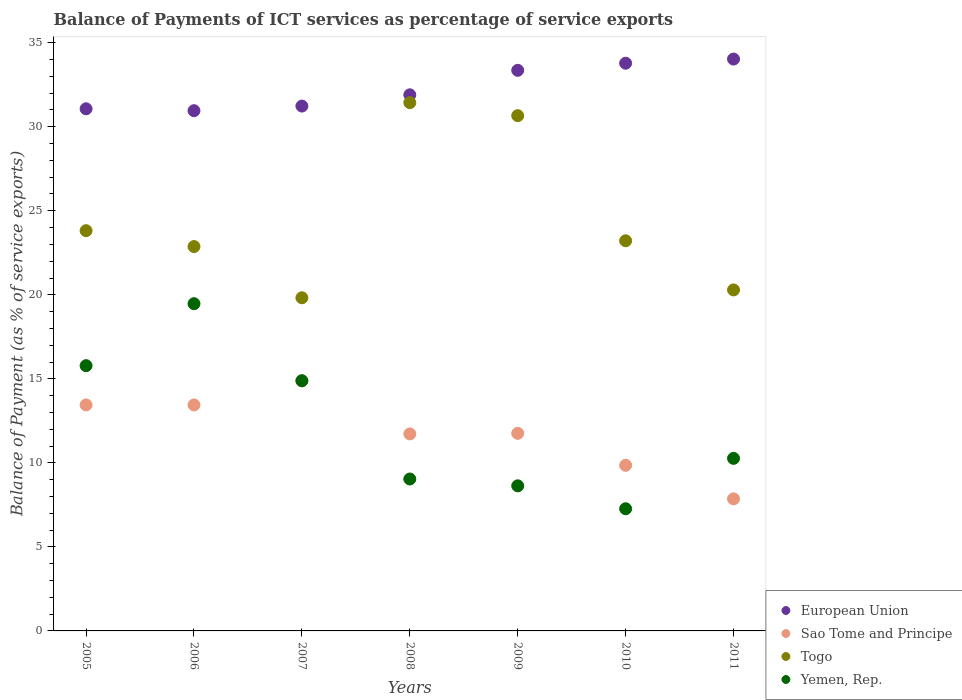How many different coloured dotlines are there?
Ensure brevity in your answer.  4. What is the balance of payments of ICT services in Togo in 2005?
Provide a succinct answer. 23.82. Across all years, what is the maximum balance of payments of ICT services in European Union?
Your answer should be compact. 34.03. Across all years, what is the minimum balance of payments of ICT services in Togo?
Your answer should be compact. 19.82. What is the total balance of payments of ICT services in Sao Tome and Principe in the graph?
Ensure brevity in your answer.  82.96. What is the difference between the balance of payments of ICT services in Togo in 2008 and that in 2010?
Make the answer very short. 8.22. What is the difference between the balance of payments of ICT services in Yemen, Rep. in 2006 and the balance of payments of ICT services in European Union in 2011?
Keep it short and to the point. -14.56. What is the average balance of payments of ICT services in Togo per year?
Make the answer very short. 24.59. In the year 2005, what is the difference between the balance of payments of ICT services in Togo and balance of payments of ICT services in Yemen, Rep.?
Provide a succinct answer. 8.03. What is the ratio of the balance of payments of ICT services in Yemen, Rep. in 2006 to that in 2009?
Your response must be concise. 2.26. Is the balance of payments of ICT services in European Union in 2008 less than that in 2010?
Offer a terse response. Yes. What is the difference between the highest and the second highest balance of payments of ICT services in Yemen, Rep.?
Offer a terse response. 3.69. What is the difference between the highest and the lowest balance of payments of ICT services in Yemen, Rep.?
Provide a short and direct response. 12.2. Is the sum of the balance of payments of ICT services in Yemen, Rep. in 2005 and 2006 greater than the maximum balance of payments of ICT services in Togo across all years?
Offer a terse response. Yes. Is it the case that in every year, the sum of the balance of payments of ICT services in Togo and balance of payments of ICT services in Sao Tome and Principe  is greater than the sum of balance of payments of ICT services in Yemen, Rep. and balance of payments of ICT services in European Union?
Your response must be concise. No. Is the balance of payments of ICT services in European Union strictly greater than the balance of payments of ICT services in Togo over the years?
Provide a succinct answer. Yes. Is the balance of payments of ICT services in European Union strictly less than the balance of payments of ICT services in Sao Tome and Principe over the years?
Offer a very short reply. No. How many dotlines are there?
Keep it short and to the point. 4. Does the graph contain any zero values?
Give a very brief answer. No. Does the graph contain grids?
Your response must be concise. No. Where does the legend appear in the graph?
Offer a terse response. Bottom right. How many legend labels are there?
Give a very brief answer. 4. How are the legend labels stacked?
Give a very brief answer. Vertical. What is the title of the graph?
Provide a succinct answer. Balance of Payments of ICT services as percentage of service exports. Does "Japan" appear as one of the legend labels in the graph?
Ensure brevity in your answer.  No. What is the label or title of the Y-axis?
Your answer should be compact. Balance of Payment (as % of service exports). What is the Balance of Payment (as % of service exports) in European Union in 2005?
Ensure brevity in your answer.  31.07. What is the Balance of Payment (as % of service exports) in Sao Tome and Principe in 2005?
Your response must be concise. 13.45. What is the Balance of Payment (as % of service exports) in Togo in 2005?
Provide a short and direct response. 23.82. What is the Balance of Payment (as % of service exports) in Yemen, Rep. in 2005?
Provide a short and direct response. 15.78. What is the Balance of Payment (as % of service exports) of European Union in 2006?
Keep it short and to the point. 30.96. What is the Balance of Payment (as % of service exports) of Sao Tome and Principe in 2006?
Offer a terse response. 13.45. What is the Balance of Payment (as % of service exports) of Togo in 2006?
Provide a short and direct response. 22.87. What is the Balance of Payment (as % of service exports) in Yemen, Rep. in 2006?
Keep it short and to the point. 19.47. What is the Balance of Payment (as % of service exports) in European Union in 2007?
Your answer should be compact. 31.23. What is the Balance of Payment (as % of service exports) in Sao Tome and Principe in 2007?
Offer a very short reply. 14.87. What is the Balance of Payment (as % of service exports) in Togo in 2007?
Provide a short and direct response. 19.82. What is the Balance of Payment (as % of service exports) in Yemen, Rep. in 2007?
Give a very brief answer. 14.89. What is the Balance of Payment (as % of service exports) in European Union in 2008?
Keep it short and to the point. 31.9. What is the Balance of Payment (as % of service exports) of Sao Tome and Principe in 2008?
Your answer should be compact. 11.72. What is the Balance of Payment (as % of service exports) in Togo in 2008?
Your answer should be compact. 31.43. What is the Balance of Payment (as % of service exports) in Yemen, Rep. in 2008?
Make the answer very short. 9.04. What is the Balance of Payment (as % of service exports) in European Union in 2009?
Give a very brief answer. 33.36. What is the Balance of Payment (as % of service exports) in Sao Tome and Principe in 2009?
Ensure brevity in your answer.  11.76. What is the Balance of Payment (as % of service exports) of Togo in 2009?
Make the answer very short. 30.66. What is the Balance of Payment (as % of service exports) in Yemen, Rep. in 2009?
Keep it short and to the point. 8.63. What is the Balance of Payment (as % of service exports) in European Union in 2010?
Your answer should be compact. 33.78. What is the Balance of Payment (as % of service exports) in Sao Tome and Principe in 2010?
Provide a succinct answer. 9.85. What is the Balance of Payment (as % of service exports) in Togo in 2010?
Offer a terse response. 23.22. What is the Balance of Payment (as % of service exports) of Yemen, Rep. in 2010?
Your response must be concise. 7.27. What is the Balance of Payment (as % of service exports) of European Union in 2011?
Offer a very short reply. 34.03. What is the Balance of Payment (as % of service exports) in Sao Tome and Principe in 2011?
Your answer should be compact. 7.86. What is the Balance of Payment (as % of service exports) of Togo in 2011?
Your answer should be very brief. 20.29. What is the Balance of Payment (as % of service exports) of Yemen, Rep. in 2011?
Your response must be concise. 10.27. Across all years, what is the maximum Balance of Payment (as % of service exports) of European Union?
Your answer should be very brief. 34.03. Across all years, what is the maximum Balance of Payment (as % of service exports) in Sao Tome and Principe?
Your response must be concise. 14.87. Across all years, what is the maximum Balance of Payment (as % of service exports) of Togo?
Your answer should be very brief. 31.43. Across all years, what is the maximum Balance of Payment (as % of service exports) of Yemen, Rep.?
Ensure brevity in your answer.  19.47. Across all years, what is the minimum Balance of Payment (as % of service exports) in European Union?
Your response must be concise. 30.96. Across all years, what is the minimum Balance of Payment (as % of service exports) of Sao Tome and Principe?
Provide a succinct answer. 7.86. Across all years, what is the minimum Balance of Payment (as % of service exports) in Togo?
Offer a very short reply. 19.82. Across all years, what is the minimum Balance of Payment (as % of service exports) in Yemen, Rep.?
Provide a succinct answer. 7.27. What is the total Balance of Payment (as % of service exports) of European Union in the graph?
Offer a terse response. 226.33. What is the total Balance of Payment (as % of service exports) in Sao Tome and Principe in the graph?
Offer a very short reply. 82.96. What is the total Balance of Payment (as % of service exports) of Togo in the graph?
Provide a succinct answer. 172.11. What is the total Balance of Payment (as % of service exports) of Yemen, Rep. in the graph?
Keep it short and to the point. 85.36. What is the difference between the Balance of Payment (as % of service exports) of European Union in 2005 and that in 2006?
Give a very brief answer. 0.11. What is the difference between the Balance of Payment (as % of service exports) of Togo in 2005 and that in 2006?
Your answer should be compact. 0.94. What is the difference between the Balance of Payment (as % of service exports) in Yemen, Rep. in 2005 and that in 2006?
Offer a very short reply. -3.69. What is the difference between the Balance of Payment (as % of service exports) in European Union in 2005 and that in 2007?
Ensure brevity in your answer.  -0.16. What is the difference between the Balance of Payment (as % of service exports) in Sao Tome and Principe in 2005 and that in 2007?
Your response must be concise. -1.43. What is the difference between the Balance of Payment (as % of service exports) of Togo in 2005 and that in 2007?
Provide a short and direct response. 3.99. What is the difference between the Balance of Payment (as % of service exports) in Yemen, Rep. in 2005 and that in 2007?
Your answer should be compact. 0.89. What is the difference between the Balance of Payment (as % of service exports) of European Union in 2005 and that in 2008?
Give a very brief answer. -0.83. What is the difference between the Balance of Payment (as % of service exports) of Sao Tome and Principe in 2005 and that in 2008?
Make the answer very short. 1.72. What is the difference between the Balance of Payment (as % of service exports) of Togo in 2005 and that in 2008?
Ensure brevity in your answer.  -7.62. What is the difference between the Balance of Payment (as % of service exports) in Yemen, Rep. in 2005 and that in 2008?
Make the answer very short. 6.74. What is the difference between the Balance of Payment (as % of service exports) of European Union in 2005 and that in 2009?
Offer a very short reply. -2.29. What is the difference between the Balance of Payment (as % of service exports) of Sao Tome and Principe in 2005 and that in 2009?
Your answer should be compact. 1.69. What is the difference between the Balance of Payment (as % of service exports) in Togo in 2005 and that in 2009?
Offer a terse response. -6.84. What is the difference between the Balance of Payment (as % of service exports) in Yemen, Rep. in 2005 and that in 2009?
Offer a very short reply. 7.15. What is the difference between the Balance of Payment (as % of service exports) in European Union in 2005 and that in 2010?
Offer a terse response. -2.71. What is the difference between the Balance of Payment (as % of service exports) of Sao Tome and Principe in 2005 and that in 2010?
Provide a short and direct response. 3.59. What is the difference between the Balance of Payment (as % of service exports) of Togo in 2005 and that in 2010?
Keep it short and to the point. 0.6. What is the difference between the Balance of Payment (as % of service exports) of Yemen, Rep. in 2005 and that in 2010?
Ensure brevity in your answer.  8.51. What is the difference between the Balance of Payment (as % of service exports) in European Union in 2005 and that in 2011?
Offer a terse response. -2.96. What is the difference between the Balance of Payment (as % of service exports) of Sao Tome and Principe in 2005 and that in 2011?
Offer a very short reply. 5.59. What is the difference between the Balance of Payment (as % of service exports) of Togo in 2005 and that in 2011?
Ensure brevity in your answer.  3.52. What is the difference between the Balance of Payment (as % of service exports) of Yemen, Rep. in 2005 and that in 2011?
Your answer should be compact. 5.51. What is the difference between the Balance of Payment (as % of service exports) in European Union in 2006 and that in 2007?
Your response must be concise. -0.27. What is the difference between the Balance of Payment (as % of service exports) in Sao Tome and Principe in 2006 and that in 2007?
Your response must be concise. -1.43. What is the difference between the Balance of Payment (as % of service exports) of Togo in 2006 and that in 2007?
Give a very brief answer. 3.05. What is the difference between the Balance of Payment (as % of service exports) in Yemen, Rep. in 2006 and that in 2007?
Offer a very short reply. 4.58. What is the difference between the Balance of Payment (as % of service exports) of European Union in 2006 and that in 2008?
Ensure brevity in your answer.  -0.94. What is the difference between the Balance of Payment (as % of service exports) in Sao Tome and Principe in 2006 and that in 2008?
Make the answer very short. 1.72. What is the difference between the Balance of Payment (as % of service exports) in Togo in 2006 and that in 2008?
Make the answer very short. -8.56. What is the difference between the Balance of Payment (as % of service exports) in Yemen, Rep. in 2006 and that in 2008?
Your answer should be very brief. 10.43. What is the difference between the Balance of Payment (as % of service exports) in European Union in 2006 and that in 2009?
Give a very brief answer. -2.4. What is the difference between the Balance of Payment (as % of service exports) of Sao Tome and Principe in 2006 and that in 2009?
Give a very brief answer. 1.69. What is the difference between the Balance of Payment (as % of service exports) of Togo in 2006 and that in 2009?
Offer a very short reply. -7.79. What is the difference between the Balance of Payment (as % of service exports) of Yemen, Rep. in 2006 and that in 2009?
Ensure brevity in your answer.  10.84. What is the difference between the Balance of Payment (as % of service exports) of European Union in 2006 and that in 2010?
Keep it short and to the point. -2.83. What is the difference between the Balance of Payment (as % of service exports) in Sao Tome and Principe in 2006 and that in 2010?
Your answer should be compact. 3.59. What is the difference between the Balance of Payment (as % of service exports) of Togo in 2006 and that in 2010?
Your answer should be compact. -0.34. What is the difference between the Balance of Payment (as % of service exports) in Yemen, Rep. in 2006 and that in 2010?
Give a very brief answer. 12.2. What is the difference between the Balance of Payment (as % of service exports) in European Union in 2006 and that in 2011?
Your answer should be very brief. -3.07. What is the difference between the Balance of Payment (as % of service exports) in Sao Tome and Principe in 2006 and that in 2011?
Your response must be concise. 5.59. What is the difference between the Balance of Payment (as % of service exports) of Togo in 2006 and that in 2011?
Give a very brief answer. 2.58. What is the difference between the Balance of Payment (as % of service exports) in Yemen, Rep. in 2006 and that in 2011?
Your answer should be compact. 9.2. What is the difference between the Balance of Payment (as % of service exports) in European Union in 2007 and that in 2008?
Give a very brief answer. -0.67. What is the difference between the Balance of Payment (as % of service exports) in Sao Tome and Principe in 2007 and that in 2008?
Offer a very short reply. 3.15. What is the difference between the Balance of Payment (as % of service exports) in Togo in 2007 and that in 2008?
Provide a short and direct response. -11.61. What is the difference between the Balance of Payment (as % of service exports) in Yemen, Rep. in 2007 and that in 2008?
Your response must be concise. 5.85. What is the difference between the Balance of Payment (as % of service exports) of European Union in 2007 and that in 2009?
Make the answer very short. -2.13. What is the difference between the Balance of Payment (as % of service exports) of Sao Tome and Principe in 2007 and that in 2009?
Give a very brief answer. 3.12. What is the difference between the Balance of Payment (as % of service exports) of Togo in 2007 and that in 2009?
Your answer should be very brief. -10.84. What is the difference between the Balance of Payment (as % of service exports) of Yemen, Rep. in 2007 and that in 2009?
Make the answer very short. 6.26. What is the difference between the Balance of Payment (as % of service exports) in European Union in 2007 and that in 2010?
Offer a very short reply. -2.55. What is the difference between the Balance of Payment (as % of service exports) in Sao Tome and Principe in 2007 and that in 2010?
Provide a succinct answer. 5.02. What is the difference between the Balance of Payment (as % of service exports) of Togo in 2007 and that in 2010?
Your answer should be very brief. -3.39. What is the difference between the Balance of Payment (as % of service exports) of Yemen, Rep. in 2007 and that in 2010?
Offer a terse response. 7.62. What is the difference between the Balance of Payment (as % of service exports) of European Union in 2007 and that in 2011?
Offer a terse response. -2.8. What is the difference between the Balance of Payment (as % of service exports) in Sao Tome and Principe in 2007 and that in 2011?
Offer a very short reply. 7.01. What is the difference between the Balance of Payment (as % of service exports) of Togo in 2007 and that in 2011?
Make the answer very short. -0.47. What is the difference between the Balance of Payment (as % of service exports) of Yemen, Rep. in 2007 and that in 2011?
Provide a succinct answer. 4.62. What is the difference between the Balance of Payment (as % of service exports) in European Union in 2008 and that in 2009?
Provide a short and direct response. -1.46. What is the difference between the Balance of Payment (as % of service exports) in Sao Tome and Principe in 2008 and that in 2009?
Ensure brevity in your answer.  -0.03. What is the difference between the Balance of Payment (as % of service exports) in Togo in 2008 and that in 2009?
Your answer should be very brief. 0.77. What is the difference between the Balance of Payment (as % of service exports) of Yemen, Rep. in 2008 and that in 2009?
Give a very brief answer. 0.41. What is the difference between the Balance of Payment (as % of service exports) in European Union in 2008 and that in 2010?
Your answer should be very brief. -1.88. What is the difference between the Balance of Payment (as % of service exports) in Sao Tome and Principe in 2008 and that in 2010?
Keep it short and to the point. 1.87. What is the difference between the Balance of Payment (as % of service exports) in Togo in 2008 and that in 2010?
Ensure brevity in your answer.  8.22. What is the difference between the Balance of Payment (as % of service exports) in Yemen, Rep. in 2008 and that in 2010?
Your response must be concise. 1.77. What is the difference between the Balance of Payment (as % of service exports) in European Union in 2008 and that in 2011?
Your answer should be compact. -2.13. What is the difference between the Balance of Payment (as % of service exports) in Sao Tome and Principe in 2008 and that in 2011?
Provide a short and direct response. 3.86. What is the difference between the Balance of Payment (as % of service exports) of Togo in 2008 and that in 2011?
Your response must be concise. 11.14. What is the difference between the Balance of Payment (as % of service exports) in Yemen, Rep. in 2008 and that in 2011?
Your answer should be compact. -1.23. What is the difference between the Balance of Payment (as % of service exports) in European Union in 2009 and that in 2010?
Your response must be concise. -0.42. What is the difference between the Balance of Payment (as % of service exports) in Sao Tome and Principe in 2009 and that in 2010?
Keep it short and to the point. 1.9. What is the difference between the Balance of Payment (as % of service exports) of Togo in 2009 and that in 2010?
Your response must be concise. 7.44. What is the difference between the Balance of Payment (as % of service exports) in Yemen, Rep. in 2009 and that in 2010?
Offer a very short reply. 1.36. What is the difference between the Balance of Payment (as % of service exports) of European Union in 2009 and that in 2011?
Give a very brief answer. -0.67. What is the difference between the Balance of Payment (as % of service exports) of Sao Tome and Principe in 2009 and that in 2011?
Offer a terse response. 3.9. What is the difference between the Balance of Payment (as % of service exports) of Togo in 2009 and that in 2011?
Your answer should be compact. 10.37. What is the difference between the Balance of Payment (as % of service exports) of Yemen, Rep. in 2009 and that in 2011?
Make the answer very short. -1.64. What is the difference between the Balance of Payment (as % of service exports) in European Union in 2010 and that in 2011?
Provide a succinct answer. -0.25. What is the difference between the Balance of Payment (as % of service exports) in Sao Tome and Principe in 2010 and that in 2011?
Your answer should be very brief. 1.99. What is the difference between the Balance of Payment (as % of service exports) in Togo in 2010 and that in 2011?
Give a very brief answer. 2.92. What is the difference between the Balance of Payment (as % of service exports) of Yemen, Rep. in 2010 and that in 2011?
Provide a short and direct response. -3. What is the difference between the Balance of Payment (as % of service exports) in European Union in 2005 and the Balance of Payment (as % of service exports) in Sao Tome and Principe in 2006?
Provide a succinct answer. 17.62. What is the difference between the Balance of Payment (as % of service exports) in European Union in 2005 and the Balance of Payment (as % of service exports) in Togo in 2006?
Your response must be concise. 8.2. What is the difference between the Balance of Payment (as % of service exports) in European Union in 2005 and the Balance of Payment (as % of service exports) in Yemen, Rep. in 2006?
Your answer should be very brief. 11.6. What is the difference between the Balance of Payment (as % of service exports) of Sao Tome and Principe in 2005 and the Balance of Payment (as % of service exports) of Togo in 2006?
Make the answer very short. -9.42. What is the difference between the Balance of Payment (as % of service exports) of Sao Tome and Principe in 2005 and the Balance of Payment (as % of service exports) of Yemen, Rep. in 2006?
Give a very brief answer. -6.02. What is the difference between the Balance of Payment (as % of service exports) in Togo in 2005 and the Balance of Payment (as % of service exports) in Yemen, Rep. in 2006?
Give a very brief answer. 4.34. What is the difference between the Balance of Payment (as % of service exports) in European Union in 2005 and the Balance of Payment (as % of service exports) in Sao Tome and Principe in 2007?
Make the answer very short. 16.2. What is the difference between the Balance of Payment (as % of service exports) in European Union in 2005 and the Balance of Payment (as % of service exports) in Togo in 2007?
Provide a succinct answer. 11.25. What is the difference between the Balance of Payment (as % of service exports) in European Union in 2005 and the Balance of Payment (as % of service exports) in Yemen, Rep. in 2007?
Keep it short and to the point. 16.18. What is the difference between the Balance of Payment (as % of service exports) of Sao Tome and Principe in 2005 and the Balance of Payment (as % of service exports) of Togo in 2007?
Provide a succinct answer. -6.38. What is the difference between the Balance of Payment (as % of service exports) of Sao Tome and Principe in 2005 and the Balance of Payment (as % of service exports) of Yemen, Rep. in 2007?
Your response must be concise. -1.44. What is the difference between the Balance of Payment (as % of service exports) in Togo in 2005 and the Balance of Payment (as % of service exports) in Yemen, Rep. in 2007?
Your response must be concise. 8.93. What is the difference between the Balance of Payment (as % of service exports) in European Union in 2005 and the Balance of Payment (as % of service exports) in Sao Tome and Principe in 2008?
Make the answer very short. 19.35. What is the difference between the Balance of Payment (as % of service exports) of European Union in 2005 and the Balance of Payment (as % of service exports) of Togo in 2008?
Provide a short and direct response. -0.36. What is the difference between the Balance of Payment (as % of service exports) in European Union in 2005 and the Balance of Payment (as % of service exports) in Yemen, Rep. in 2008?
Make the answer very short. 22.03. What is the difference between the Balance of Payment (as % of service exports) in Sao Tome and Principe in 2005 and the Balance of Payment (as % of service exports) in Togo in 2008?
Ensure brevity in your answer.  -17.99. What is the difference between the Balance of Payment (as % of service exports) of Sao Tome and Principe in 2005 and the Balance of Payment (as % of service exports) of Yemen, Rep. in 2008?
Ensure brevity in your answer.  4.41. What is the difference between the Balance of Payment (as % of service exports) in Togo in 2005 and the Balance of Payment (as % of service exports) in Yemen, Rep. in 2008?
Your answer should be compact. 14.78. What is the difference between the Balance of Payment (as % of service exports) of European Union in 2005 and the Balance of Payment (as % of service exports) of Sao Tome and Principe in 2009?
Provide a succinct answer. 19.31. What is the difference between the Balance of Payment (as % of service exports) of European Union in 2005 and the Balance of Payment (as % of service exports) of Togo in 2009?
Make the answer very short. 0.41. What is the difference between the Balance of Payment (as % of service exports) in European Union in 2005 and the Balance of Payment (as % of service exports) in Yemen, Rep. in 2009?
Your answer should be compact. 22.44. What is the difference between the Balance of Payment (as % of service exports) of Sao Tome and Principe in 2005 and the Balance of Payment (as % of service exports) of Togo in 2009?
Your answer should be very brief. -17.21. What is the difference between the Balance of Payment (as % of service exports) in Sao Tome and Principe in 2005 and the Balance of Payment (as % of service exports) in Yemen, Rep. in 2009?
Provide a succinct answer. 4.81. What is the difference between the Balance of Payment (as % of service exports) in Togo in 2005 and the Balance of Payment (as % of service exports) in Yemen, Rep. in 2009?
Your answer should be very brief. 15.18. What is the difference between the Balance of Payment (as % of service exports) of European Union in 2005 and the Balance of Payment (as % of service exports) of Sao Tome and Principe in 2010?
Keep it short and to the point. 21.22. What is the difference between the Balance of Payment (as % of service exports) of European Union in 2005 and the Balance of Payment (as % of service exports) of Togo in 2010?
Your response must be concise. 7.85. What is the difference between the Balance of Payment (as % of service exports) in European Union in 2005 and the Balance of Payment (as % of service exports) in Yemen, Rep. in 2010?
Your response must be concise. 23.8. What is the difference between the Balance of Payment (as % of service exports) of Sao Tome and Principe in 2005 and the Balance of Payment (as % of service exports) of Togo in 2010?
Give a very brief answer. -9.77. What is the difference between the Balance of Payment (as % of service exports) of Sao Tome and Principe in 2005 and the Balance of Payment (as % of service exports) of Yemen, Rep. in 2010?
Offer a terse response. 6.18. What is the difference between the Balance of Payment (as % of service exports) in Togo in 2005 and the Balance of Payment (as % of service exports) in Yemen, Rep. in 2010?
Your response must be concise. 16.55. What is the difference between the Balance of Payment (as % of service exports) of European Union in 2005 and the Balance of Payment (as % of service exports) of Sao Tome and Principe in 2011?
Give a very brief answer. 23.21. What is the difference between the Balance of Payment (as % of service exports) of European Union in 2005 and the Balance of Payment (as % of service exports) of Togo in 2011?
Your response must be concise. 10.78. What is the difference between the Balance of Payment (as % of service exports) in European Union in 2005 and the Balance of Payment (as % of service exports) in Yemen, Rep. in 2011?
Offer a very short reply. 20.8. What is the difference between the Balance of Payment (as % of service exports) of Sao Tome and Principe in 2005 and the Balance of Payment (as % of service exports) of Togo in 2011?
Ensure brevity in your answer.  -6.84. What is the difference between the Balance of Payment (as % of service exports) of Sao Tome and Principe in 2005 and the Balance of Payment (as % of service exports) of Yemen, Rep. in 2011?
Offer a very short reply. 3.18. What is the difference between the Balance of Payment (as % of service exports) in Togo in 2005 and the Balance of Payment (as % of service exports) in Yemen, Rep. in 2011?
Keep it short and to the point. 13.55. What is the difference between the Balance of Payment (as % of service exports) of European Union in 2006 and the Balance of Payment (as % of service exports) of Sao Tome and Principe in 2007?
Offer a very short reply. 16.08. What is the difference between the Balance of Payment (as % of service exports) of European Union in 2006 and the Balance of Payment (as % of service exports) of Togo in 2007?
Offer a terse response. 11.13. What is the difference between the Balance of Payment (as % of service exports) in European Union in 2006 and the Balance of Payment (as % of service exports) in Yemen, Rep. in 2007?
Provide a succinct answer. 16.07. What is the difference between the Balance of Payment (as % of service exports) of Sao Tome and Principe in 2006 and the Balance of Payment (as % of service exports) of Togo in 2007?
Give a very brief answer. -6.38. What is the difference between the Balance of Payment (as % of service exports) in Sao Tome and Principe in 2006 and the Balance of Payment (as % of service exports) in Yemen, Rep. in 2007?
Make the answer very short. -1.44. What is the difference between the Balance of Payment (as % of service exports) of Togo in 2006 and the Balance of Payment (as % of service exports) of Yemen, Rep. in 2007?
Provide a short and direct response. 7.98. What is the difference between the Balance of Payment (as % of service exports) of European Union in 2006 and the Balance of Payment (as % of service exports) of Sao Tome and Principe in 2008?
Provide a short and direct response. 19.23. What is the difference between the Balance of Payment (as % of service exports) of European Union in 2006 and the Balance of Payment (as % of service exports) of Togo in 2008?
Your response must be concise. -0.48. What is the difference between the Balance of Payment (as % of service exports) in European Union in 2006 and the Balance of Payment (as % of service exports) in Yemen, Rep. in 2008?
Offer a very short reply. 21.92. What is the difference between the Balance of Payment (as % of service exports) in Sao Tome and Principe in 2006 and the Balance of Payment (as % of service exports) in Togo in 2008?
Give a very brief answer. -17.99. What is the difference between the Balance of Payment (as % of service exports) in Sao Tome and Principe in 2006 and the Balance of Payment (as % of service exports) in Yemen, Rep. in 2008?
Your answer should be compact. 4.41. What is the difference between the Balance of Payment (as % of service exports) of Togo in 2006 and the Balance of Payment (as % of service exports) of Yemen, Rep. in 2008?
Give a very brief answer. 13.83. What is the difference between the Balance of Payment (as % of service exports) in European Union in 2006 and the Balance of Payment (as % of service exports) in Sao Tome and Principe in 2009?
Provide a succinct answer. 19.2. What is the difference between the Balance of Payment (as % of service exports) in European Union in 2006 and the Balance of Payment (as % of service exports) in Togo in 2009?
Provide a short and direct response. 0.3. What is the difference between the Balance of Payment (as % of service exports) in European Union in 2006 and the Balance of Payment (as % of service exports) in Yemen, Rep. in 2009?
Your response must be concise. 22.32. What is the difference between the Balance of Payment (as % of service exports) in Sao Tome and Principe in 2006 and the Balance of Payment (as % of service exports) in Togo in 2009?
Provide a short and direct response. -17.21. What is the difference between the Balance of Payment (as % of service exports) of Sao Tome and Principe in 2006 and the Balance of Payment (as % of service exports) of Yemen, Rep. in 2009?
Keep it short and to the point. 4.81. What is the difference between the Balance of Payment (as % of service exports) of Togo in 2006 and the Balance of Payment (as % of service exports) of Yemen, Rep. in 2009?
Provide a succinct answer. 14.24. What is the difference between the Balance of Payment (as % of service exports) in European Union in 2006 and the Balance of Payment (as % of service exports) in Sao Tome and Principe in 2010?
Keep it short and to the point. 21.1. What is the difference between the Balance of Payment (as % of service exports) in European Union in 2006 and the Balance of Payment (as % of service exports) in Togo in 2010?
Provide a succinct answer. 7.74. What is the difference between the Balance of Payment (as % of service exports) of European Union in 2006 and the Balance of Payment (as % of service exports) of Yemen, Rep. in 2010?
Your answer should be compact. 23.69. What is the difference between the Balance of Payment (as % of service exports) in Sao Tome and Principe in 2006 and the Balance of Payment (as % of service exports) in Togo in 2010?
Give a very brief answer. -9.77. What is the difference between the Balance of Payment (as % of service exports) in Sao Tome and Principe in 2006 and the Balance of Payment (as % of service exports) in Yemen, Rep. in 2010?
Keep it short and to the point. 6.18. What is the difference between the Balance of Payment (as % of service exports) in Togo in 2006 and the Balance of Payment (as % of service exports) in Yemen, Rep. in 2010?
Give a very brief answer. 15.6. What is the difference between the Balance of Payment (as % of service exports) in European Union in 2006 and the Balance of Payment (as % of service exports) in Sao Tome and Principe in 2011?
Provide a short and direct response. 23.1. What is the difference between the Balance of Payment (as % of service exports) in European Union in 2006 and the Balance of Payment (as % of service exports) in Togo in 2011?
Keep it short and to the point. 10.66. What is the difference between the Balance of Payment (as % of service exports) of European Union in 2006 and the Balance of Payment (as % of service exports) of Yemen, Rep. in 2011?
Offer a terse response. 20.69. What is the difference between the Balance of Payment (as % of service exports) in Sao Tome and Principe in 2006 and the Balance of Payment (as % of service exports) in Togo in 2011?
Give a very brief answer. -6.84. What is the difference between the Balance of Payment (as % of service exports) in Sao Tome and Principe in 2006 and the Balance of Payment (as % of service exports) in Yemen, Rep. in 2011?
Your answer should be very brief. 3.18. What is the difference between the Balance of Payment (as % of service exports) in Togo in 2006 and the Balance of Payment (as % of service exports) in Yemen, Rep. in 2011?
Provide a succinct answer. 12.6. What is the difference between the Balance of Payment (as % of service exports) of European Union in 2007 and the Balance of Payment (as % of service exports) of Sao Tome and Principe in 2008?
Offer a terse response. 19.51. What is the difference between the Balance of Payment (as % of service exports) of European Union in 2007 and the Balance of Payment (as % of service exports) of Togo in 2008?
Ensure brevity in your answer.  -0.2. What is the difference between the Balance of Payment (as % of service exports) of European Union in 2007 and the Balance of Payment (as % of service exports) of Yemen, Rep. in 2008?
Offer a very short reply. 22.19. What is the difference between the Balance of Payment (as % of service exports) in Sao Tome and Principe in 2007 and the Balance of Payment (as % of service exports) in Togo in 2008?
Provide a short and direct response. -16.56. What is the difference between the Balance of Payment (as % of service exports) in Sao Tome and Principe in 2007 and the Balance of Payment (as % of service exports) in Yemen, Rep. in 2008?
Provide a short and direct response. 5.83. What is the difference between the Balance of Payment (as % of service exports) in Togo in 2007 and the Balance of Payment (as % of service exports) in Yemen, Rep. in 2008?
Your response must be concise. 10.78. What is the difference between the Balance of Payment (as % of service exports) of European Union in 2007 and the Balance of Payment (as % of service exports) of Sao Tome and Principe in 2009?
Your answer should be compact. 19.47. What is the difference between the Balance of Payment (as % of service exports) of European Union in 2007 and the Balance of Payment (as % of service exports) of Togo in 2009?
Ensure brevity in your answer.  0.57. What is the difference between the Balance of Payment (as % of service exports) in European Union in 2007 and the Balance of Payment (as % of service exports) in Yemen, Rep. in 2009?
Offer a terse response. 22.6. What is the difference between the Balance of Payment (as % of service exports) of Sao Tome and Principe in 2007 and the Balance of Payment (as % of service exports) of Togo in 2009?
Your answer should be compact. -15.79. What is the difference between the Balance of Payment (as % of service exports) of Sao Tome and Principe in 2007 and the Balance of Payment (as % of service exports) of Yemen, Rep. in 2009?
Provide a short and direct response. 6.24. What is the difference between the Balance of Payment (as % of service exports) of Togo in 2007 and the Balance of Payment (as % of service exports) of Yemen, Rep. in 2009?
Your answer should be very brief. 11.19. What is the difference between the Balance of Payment (as % of service exports) in European Union in 2007 and the Balance of Payment (as % of service exports) in Sao Tome and Principe in 2010?
Your answer should be compact. 21.38. What is the difference between the Balance of Payment (as % of service exports) of European Union in 2007 and the Balance of Payment (as % of service exports) of Togo in 2010?
Keep it short and to the point. 8.02. What is the difference between the Balance of Payment (as % of service exports) of European Union in 2007 and the Balance of Payment (as % of service exports) of Yemen, Rep. in 2010?
Your answer should be compact. 23.96. What is the difference between the Balance of Payment (as % of service exports) of Sao Tome and Principe in 2007 and the Balance of Payment (as % of service exports) of Togo in 2010?
Provide a succinct answer. -8.34. What is the difference between the Balance of Payment (as % of service exports) of Sao Tome and Principe in 2007 and the Balance of Payment (as % of service exports) of Yemen, Rep. in 2010?
Your response must be concise. 7.6. What is the difference between the Balance of Payment (as % of service exports) in Togo in 2007 and the Balance of Payment (as % of service exports) in Yemen, Rep. in 2010?
Give a very brief answer. 12.55. What is the difference between the Balance of Payment (as % of service exports) in European Union in 2007 and the Balance of Payment (as % of service exports) in Sao Tome and Principe in 2011?
Offer a terse response. 23.37. What is the difference between the Balance of Payment (as % of service exports) of European Union in 2007 and the Balance of Payment (as % of service exports) of Togo in 2011?
Your answer should be compact. 10.94. What is the difference between the Balance of Payment (as % of service exports) in European Union in 2007 and the Balance of Payment (as % of service exports) in Yemen, Rep. in 2011?
Give a very brief answer. 20.96. What is the difference between the Balance of Payment (as % of service exports) of Sao Tome and Principe in 2007 and the Balance of Payment (as % of service exports) of Togo in 2011?
Offer a very short reply. -5.42. What is the difference between the Balance of Payment (as % of service exports) in Sao Tome and Principe in 2007 and the Balance of Payment (as % of service exports) in Yemen, Rep. in 2011?
Your answer should be very brief. 4.61. What is the difference between the Balance of Payment (as % of service exports) of Togo in 2007 and the Balance of Payment (as % of service exports) of Yemen, Rep. in 2011?
Offer a terse response. 9.55. What is the difference between the Balance of Payment (as % of service exports) in European Union in 2008 and the Balance of Payment (as % of service exports) in Sao Tome and Principe in 2009?
Give a very brief answer. 20.14. What is the difference between the Balance of Payment (as % of service exports) of European Union in 2008 and the Balance of Payment (as % of service exports) of Togo in 2009?
Ensure brevity in your answer.  1.24. What is the difference between the Balance of Payment (as % of service exports) in European Union in 2008 and the Balance of Payment (as % of service exports) in Yemen, Rep. in 2009?
Give a very brief answer. 23.27. What is the difference between the Balance of Payment (as % of service exports) of Sao Tome and Principe in 2008 and the Balance of Payment (as % of service exports) of Togo in 2009?
Ensure brevity in your answer.  -18.94. What is the difference between the Balance of Payment (as % of service exports) of Sao Tome and Principe in 2008 and the Balance of Payment (as % of service exports) of Yemen, Rep. in 2009?
Keep it short and to the point. 3.09. What is the difference between the Balance of Payment (as % of service exports) of Togo in 2008 and the Balance of Payment (as % of service exports) of Yemen, Rep. in 2009?
Give a very brief answer. 22.8. What is the difference between the Balance of Payment (as % of service exports) in European Union in 2008 and the Balance of Payment (as % of service exports) in Sao Tome and Principe in 2010?
Provide a succinct answer. 22.05. What is the difference between the Balance of Payment (as % of service exports) in European Union in 2008 and the Balance of Payment (as % of service exports) in Togo in 2010?
Make the answer very short. 8.68. What is the difference between the Balance of Payment (as % of service exports) of European Union in 2008 and the Balance of Payment (as % of service exports) of Yemen, Rep. in 2010?
Offer a very short reply. 24.63. What is the difference between the Balance of Payment (as % of service exports) of Sao Tome and Principe in 2008 and the Balance of Payment (as % of service exports) of Togo in 2010?
Offer a terse response. -11.49. What is the difference between the Balance of Payment (as % of service exports) in Sao Tome and Principe in 2008 and the Balance of Payment (as % of service exports) in Yemen, Rep. in 2010?
Ensure brevity in your answer.  4.45. What is the difference between the Balance of Payment (as % of service exports) in Togo in 2008 and the Balance of Payment (as % of service exports) in Yemen, Rep. in 2010?
Provide a succinct answer. 24.16. What is the difference between the Balance of Payment (as % of service exports) in European Union in 2008 and the Balance of Payment (as % of service exports) in Sao Tome and Principe in 2011?
Provide a succinct answer. 24.04. What is the difference between the Balance of Payment (as % of service exports) of European Union in 2008 and the Balance of Payment (as % of service exports) of Togo in 2011?
Offer a terse response. 11.61. What is the difference between the Balance of Payment (as % of service exports) of European Union in 2008 and the Balance of Payment (as % of service exports) of Yemen, Rep. in 2011?
Provide a succinct answer. 21.63. What is the difference between the Balance of Payment (as % of service exports) in Sao Tome and Principe in 2008 and the Balance of Payment (as % of service exports) in Togo in 2011?
Your answer should be compact. -8.57. What is the difference between the Balance of Payment (as % of service exports) in Sao Tome and Principe in 2008 and the Balance of Payment (as % of service exports) in Yemen, Rep. in 2011?
Provide a short and direct response. 1.46. What is the difference between the Balance of Payment (as % of service exports) of Togo in 2008 and the Balance of Payment (as % of service exports) of Yemen, Rep. in 2011?
Ensure brevity in your answer.  21.17. What is the difference between the Balance of Payment (as % of service exports) in European Union in 2009 and the Balance of Payment (as % of service exports) in Sao Tome and Principe in 2010?
Keep it short and to the point. 23.5. What is the difference between the Balance of Payment (as % of service exports) of European Union in 2009 and the Balance of Payment (as % of service exports) of Togo in 2010?
Your answer should be very brief. 10.14. What is the difference between the Balance of Payment (as % of service exports) in European Union in 2009 and the Balance of Payment (as % of service exports) in Yemen, Rep. in 2010?
Keep it short and to the point. 26.09. What is the difference between the Balance of Payment (as % of service exports) in Sao Tome and Principe in 2009 and the Balance of Payment (as % of service exports) in Togo in 2010?
Offer a very short reply. -11.46. What is the difference between the Balance of Payment (as % of service exports) of Sao Tome and Principe in 2009 and the Balance of Payment (as % of service exports) of Yemen, Rep. in 2010?
Your answer should be very brief. 4.49. What is the difference between the Balance of Payment (as % of service exports) of Togo in 2009 and the Balance of Payment (as % of service exports) of Yemen, Rep. in 2010?
Provide a succinct answer. 23.39. What is the difference between the Balance of Payment (as % of service exports) in European Union in 2009 and the Balance of Payment (as % of service exports) in Sao Tome and Principe in 2011?
Give a very brief answer. 25.5. What is the difference between the Balance of Payment (as % of service exports) in European Union in 2009 and the Balance of Payment (as % of service exports) in Togo in 2011?
Ensure brevity in your answer.  13.07. What is the difference between the Balance of Payment (as % of service exports) of European Union in 2009 and the Balance of Payment (as % of service exports) of Yemen, Rep. in 2011?
Provide a short and direct response. 23.09. What is the difference between the Balance of Payment (as % of service exports) of Sao Tome and Principe in 2009 and the Balance of Payment (as % of service exports) of Togo in 2011?
Offer a very short reply. -8.53. What is the difference between the Balance of Payment (as % of service exports) in Sao Tome and Principe in 2009 and the Balance of Payment (as % of service exports) in Yemen, Rep. in 2011?
Provide a short and direct response. 1.49. What is the difference between the Balance of Payment (as % of service exports) of Togo in 2009 and the Balance of Payment (as % of service exports) of Yemen, Rep. in 2011?
Your answer should be compact. 20.39. What is the difference between the Balance of Payment (as % of service exports) in European Union in 2010 and the Balance of Payment (as % of service exports) in Sao Tome and Principe in 2011?
Your answer should be compact. 25.92. What is the difference between the Balance of Payment (as % of service exports) in European Union in 2010 and the Balance of Payment (as % of service exports) in Togo in 2011?
Your answer should be very brief. 13.49. What is the difference between the Balance of Payment (as % of service exports) of European Union in 2010 and the Balance of Payment (as % of service exports) of Yemen, Rep. in 2011?
Provide a succinct answer. 23.51. What is the difference between the Balance of Payment (as % of service exports) in Sao Tome and Principe in 2010 and the Balance of Payment (as % of service exports) in Togo in 2011?
Keep it short and to the point. -10.44. What is the difference between the Balance of Payment (as % of service exports) of Sao Tome and Principe in 2010 and the Balance of Payment (as % of service exports) of Yemen, Rep. in 2011?
Provide a short and direct response. -0.41. What is the difference between the Balance of Payment (as % of service exports) in Togo in 2010 and the Balance of Payment (as % of service exports) in Yemen, Rep. in 2011?
Your response must be concise. 12.95. What is the average Balance of Payment (as % of service exports) in European Union per year?
Your answer should be very brief. 32.33. What is the average Balance of Payment (as % of service exports) of Sao Tome and Principe per year?
Make the answer very short. 11.85. What is the average Balance of Payment (as % of service exports) in Togo per year?
Your answer should be compact. 24.59. What is the average Balance of Payment (as % of service exports) of Yemen, Rep. per year?
Offer a terse response. 12.19. In the year 2005, what is the difference between the Balance of Payment (as % of service exports) in European Union and Balance of Payment (as % of service exports) in Sao Tome and Principe?
Offer a very short reply. 17.62. In the year 2005, what is the difference between the Balance of Payment (as % of service exports) of European Union and Balance of Payment (as % of service exports) of Togo?
Your answer should be very brief. 7.25. In the year 2005, what is the difference between the Balance of Payment (as % of service exports) in European Union and Balance of Payment (as % of service exports) in Yemen, Rep.?
Your answer should be compact. 15.29. In the year 2005, what is the difference between the Balance of Payment (as % of service exports) in Sao Tome and Principe and Balance of Payment (as % of service exports) in Togo?
Your answer should be compact. -10.37. In the year 2005, what is the difference between the Balance of Payment (as % of service exports) in Sao Tome and Principe and Balance of Payment (as % of service exports) in Yemen, Rep.?
Your response must be concise. -2.34. In the year 2005, what is the difference between the Balance of Payment (as % of service exports) in Togo and Balance of Payment (as % of service exports) in Yemen, Rep.?
Provide a short and direct response. 8.03. In the year 2006, what is the difference between the Balance of Payment (as % of service exports) of European Union and Balance of Payment (as % of service exports) of Sao Tome and Principe?
Your response must be concise. 17.51. In the year 2006, what is the difference between the Balance of Payment (as % of service exports) of European Union and Balance of Payment (as % of service exports) of Togo?
Your answer should be compact. 8.09. In the year 2006, what is the difference between the Balance of Payment (as % of service exports) in European Union and Balance of Payment (as % of service exports) in Yemen, Rep.?
Your answer should be very brief. 11.48. In the year 2006, what is the difference between the Balance of Payment (as % of service exports) in Sao Tome and Principe and Balance of Payment (as % of service exports) in Togo?
Keep it short and to the point. -9.42. In the year 2006, what is the difference between the Balance of Payment (as % of service exports) of Sao Tome and Principe and Balance of Payment (as % of service exports) of Yemen, Rep.?
Offer a terse response. -6.02. In the year 2006, what is the difference between the Balance of Payment (as % of service exports) of Togo and Balance of Payment (as % of service exports) of Yemen, Rep.?
Provide a short and direct response. 3.4. In the year 2007, what is the difference between the Balance of Payment (as % of service exports) in European Union and Balance of Payment (as % of service exports) in Sao Tome and Principe?
Provide a short and direct response. 16.36. In the year 2007, what is the difference between the Balance of Payment (as % of service exports) in European Union and Balance of Payment (as % of service exports) in Togo?
Your answer should be very brief. 11.41. In the year 2007, what is the difference between the Balance of Payment (as % of service exports) of European Union and Balance of Payment (as % of service exports) of Yemen, Rep.?
Offer a terse response. 16.34. In the year 2007, what is the difference between the Balance of Payment (as % of service exports) of Sao Tome and Principe and Balance of Payment (as % of service exports) of Togo?
Make the answer very short. -4.95. In the year 2007, what is the difference between the Balance of Payment (as % of service exports) in Sao Tome and Principe and Balance of Payment (as % of service exports) in Yemen, Rep.?
Your response must be concise. -0.02. In the year 2007, what is the difference between the Balance of Payment (as % of service exports) in Togo and Balance of Payment (as % of service exports) in Yemen, Rep.?
Keep it short and to the point. 4.93. In the year 2008, what is the difference between the Balance of Payment (as % of service exports) of European Union and Balance of Payment (as % of service exports) of Sao Tome and Principe?
Offer a terse response. 20.18. In the year 2008, what is the difference between the Balance of Payment (as % of service exports) of European Union and Balance of Payment (as % of service exports) of Togo?
Offer a terse response. 0.47. In the year 2008, what is the difference between the Balance of Payment (as % of service exports) of European Union and Balance of Payment (as % of service exports) of Yemen, Rep.?
Keep it short and to the point. 22.86. In the year 2008, what is the difference between the Balance of Payment (as % of service exports) of Sao Tome and Principe and Balance of Payment (as % of service exports) of Togo?
Offer a terse response. -19.71. In the year 2008, what is the difference between the Balance of Payment (as % of service exports) of Sao Tome and Principe and Balance of Payment (as % of service exports) of Yemen, Rep.?
Keep it short and to the point. 2.68. In the year 2008, what is the difference between the Balance of Payment (as % of service exports) of Togo and Balance of Payment (as % of service exports) of Yemen, Rep.?
Offer a very short reply. 22.39. In the year 2009, what is the difference between the Balance of Payment (as % of service exports) in European Union and Balance of Payment (as % of service exports) in Sao Tome and Principe?
Your answer should be very brief. 21.6. In the year 2009, what is the difference between the Balance of Payment (as % of service exports) of European Union and Balance of Payment (as % of service exports) of Togo?
Your answer should be compact. 2.7. In the year 2009, what is the difference between the Balance of Payment (as % of service exports) of European Union and Balance of Payment (as % of service exports) of Yemen, Rep.?
Keep it short and to the point. 24.73. In the year 2009, what is the difference between the Balance of Payment (as % of service exports) of Sao Tome and Principe and Balance of Payment (as % of service exports) of Togo?
Provide a short and direct response. -18.9. In the year 2009, what is the difference between the Balance of Payment (as % of service exports) of Sao Tome and Principe and Balance of Payment (as % of service exports) of Yemen, Rep.?
Give a very brief answer. 3.12. In the year 2009, what is the difference between the Balance of Payment (as % of service exports) in Togo and Balance of Payment (as % of service exports) in Yemen, Rep.?
Keep it short and to the point. 22.03. In the year 2010, what is the difference between the Balance of Payment (as % of service exports) of European Union and Balance of Payment (as % of service exports) of Sao Tome and Principe?
Ensure brevity in your answer.  23.93. In the year 2010, what is the difference between the Balance of Payment (as % of service exports) in European Union and Balance of Payment (as % of service exports) in Togo?
Provide a short and direct response. 10.57. In the year 2010, what is the difference between the Balance of Payment (as % of service exports) in European Union and Balance of Payment (as % of service exports) in Yemen, Rep.?
Provide a succinct answer. 26.51. In the year 2010, what is the difference between the Balance of Payment (as % of service exports) of Sao Tome and Principe and Balance of Payment (as % of service exports) of Togo?
Offer a terse response. -13.36. In the year 2010, what is the difference between the Balance of Payment (as % of service exports) in Sao Tome and Principe and Balance of Payment (as % of service exports) in Yemen, Rep.?
Ensure brevity in your answer.  2.58. In the year 2010, what is the difference between the Balance of Payment (as % of service exports) in Togo and Balance of Payment (as % of service exports) in Yemen, Rep.?
Give a very brief answer. 15.95. In the year 2011, what is the difference between the Balance of Payment (as % of service exports) of European Union and Balance of Payment (as % of service exports) of Sao Tome and Principe?
Give a very brief answer. 26.17. In the year 2011, what is the difference between the Balance of Payment (as % of service exports) in European Union and Balance of Payment (as % of service exports) in Togo?
Give a very brief answer. 13.74. In the year 2011, what is the difference between the Balance of Payment (as % of service exports) in European Union and Balance of Payment (as % of service exports) in Yemen, Rep.?
Offer a very short reply. 23.76. In the year 2011, what is the difference between the Balance of Payment (as % of service exports) of Sao Tome and Principe and Balance of Payment (as % of service exports) of Togo?
Offer a very short reply. -12.43. In the year 2011, what is the difference between the Balance of Payment (as % of service exports) of Sao Tome and Principe and Balance of Payment (as % of service exports) of Yemen, Rep.?
Keep it short and to the point. -2.41. In the year 2011, what is the difference between the Balance of Payment (as % of service exports) of Togo and Balance of Payment (as % of service exports) of Yemen, Rep.?
Make the answer very short. 10.02. What is the ratio of the Balance of Payment (as % of service exports) of European Union in 2005 to that in 2006?
Provide a short and direct response. 1. What is the ratio of the Balance of Payment (as % of service exports) of Sao Tome and Principe in 2005 to that in 2006?
Your answer should be very brief. 1. What is the ratio of the Balance of Payment (as % of service exports) in Togo in 2005 to that in 2006?
Give a very brief answer. 1.04. What is the ratio of the Balance of Payment (as % of service exports) of Yemen, Rep. in 2005 to that in 2006?
Ensure brevity in your answer.  0.81. What is the ratio of the Balance of Payment (as % of service exports) in European Union in 2005 to that in 2007?
Offer a terse response. 0.99. What is the ratio of the Balance of Payment (as % of service exports) of Sao Tome and Principe in 2005 to that in 2007?
Give a very brief answer. 0.9. What is the ratio of the Balance of Payment (as % of service exports) of Togo in 2005 to that in 2007?
Provide a succinct answer. 1.2. What is the ratio of the Balance of Payment (as % of service exports) of Yemen, Rep. in 2005 to that in 2007?
Ensure brevity in your answer.  1.06. What is the ratio of the Balance of Payment (as % of service exports) in European Union in 2005 to that in 2008?
Offer a terse response. 0.97. What is the ratio of the Balance of Payment (as % of service exports) of Sao Tome and Principe in 2005 to that in 2008?
Make the answer very short. 1.15. What is the ratio of the Balance of Payment (as % of service exports) of Togo in 2005 to that in 2008?
Make the answer very short. 0.76. What is the ratio of the Balance of Payment (as % of service exports) in Yemen, Rep. in 2005 to that in 2008?
Provide a short and direct response. 1.75. What is the ratio of the Balance of Payment (as % of service exports) in European Union in 2005 to that in 2009?
Offer a terse response. 0.93. What is the ratio of the Balance of Payment (as % of service exports) of Sao Tome and Principe in 2005 to that in 2009?
Provide a succinct answer. 1.14. What is the ratio of the Balance of Payment (as % of service exports) in Togo in 2005 to that in 2009?
Your response must be concise. 0.78. What is the ratio of the Balance of Payment (as % of service exports) of Yemen, Rep. in 2005 to that in 2009?
Your answer should be very brief. 1.83. What is the ratio of the Balance of Payment (as % of service exports) in European Union in 2005 to that in 2010?
Your answer should be compact. 0.92. What is the ratio of the Balance of Payment (as % of service exports) in Sao Tome and Principe in 2005 to that in 2010?
Your answer should be compact. 1.36. What is the ratio of the Balance of Payment (as % of service exports) in Togo in 2005 to that in 2010?
Your response must be concise. 1.03. What is the ratio of the Balance of Payment (as % of service exports) in Yemen, Rep. in 2005 to that in 2010?
Ensure brevity in your answer.  2.17. What is the ratio of the Balance of Payment (as % of service exports) in European Union in 2005 to that in 2011?
Provide a succinct answer. 0.91. What is the ratio of the Balance of Payment (as % of service exports) of Sao Tome and Principe in 2005 to that in 2011?
Keep it short and to the point. 1.71. What is the ratio of the Balance of Payment (as % of service exports) of Togo in 2005 to that in 2011?
Provide a succinct answer. 1.17. What is the ratio of the Balance of Payment (as % of service exports) of Yemen, Rep. in 2005 to that in 2011?
Keep it short and to the point. 1.54. What is the ratio of the Balance of Payment (as % of service exports) in Sao Tome and Principe in 2006 to that in 2007?
Ensure brevity in your answer.  0.9. What is the ratio of the Balance of Payment (as % of service exports) in Togo in 2006 to that in 2007?
Give a very brief answer. 1.15. What is the ratio of the Balance of Payment (as % of service exports) in Yemen, Rep. in 2006 to that in 2007?
Keep it short and to the point. 1.31. What is the ratio of the Balance of Payment (as % of service exports) of European Union in 2006 to that in 2008?
Your answer should be very brief. 0.97. What is the ratio of the Balance of Payment (as % of service exports) in Sao Tome and Principe in 2006 to that in 2008?
Your response must be concise. 1.15. What is the ratio of the Balance of Payment (as % of service exports) of Togo in 2006 to that in 2008?
Make the answer very short. 0.73. What is the ratio of the Balance of Payment (as % of service exports) in Yemen, Rep. in 2006 to that in 2008?
Your response must be concise. 2.15. What is the ratio of the Balance of Payment (as % of service exports) of European Union in 2006 to that in 2009?
Your response must be concise. 0.93. What is the ratio of the Balance of Payment (as % of service exports) in Sao Tome and Principe in 2006 to that in 2009?
Keep it short and to the point. 1.14. What is the ratio of the Balance of Payment (as % of service exports) in Togo in 2006 to that in 2009?
Your answer should be compact. 0.75. What is the ratio of the Balance of Payment (as % of service exports) of Yemen, Rep. in 2006 to that in 2009?
Give a very brief answer. 2.26. What is the ratio of the Balance of Payment (as % of service exports) in European Union in 2006 to that in 2010?
Make the answer very short. 0.92. What is the ratio of the Balance of Payment (as % of service exports) in Sao Tome and Principe in 2006 to that in 2010?
Ensure brevity in your answer.  1.36. What is the ratio of the Balance of Payment (as % of service exports) of Togo in 2006 to that in 2010?
Give a very brief answer. 0.99. What is the ratio of the Balance of Payment (as % of service exports) in Yemen, Rep. in 2006 to that in 2010?
Give a very brief answer. 2.68. What is the ratio of the Balance of Payment (as % of service exports) of European Union in 2006 to that in 2011?
Ensure brevity in your answer.  0.91. What is the ratio of the Balance of Payment (as % of service exports) of Sao Tome and Principe in 2006 to that in 2011?
Your answer should be very brief. 1.71. What is the ratio of the Balance of Payment (as % of service exports) in Togo in 2006 to that in 2011?
Ensure brevity in your answer.  1.13. What is the ratio of the Balance of Payment (as % of service exports) of Yemen, Rep. in 2006 to that in 2011?
Your answer should be very brief. 1.9. What is the ratio of the Balance of Payment (as % of service exports) of European Union in 2007 to that in 2008?
Your response must be concise. 0.98. What is the ratio of the Balance of Payment (as % of service exports) in Sao Tome and Principe in 2007 to that in 2008?
Give a very brief answer. 1.27. What is the ratio of the Balance of Payment (as % of service exports) in Togo in 2007 to that in 2008?
Offer a very short reply. 0.63. What is the ratio of the Balance of Payment (as % of service exports) in Yemen, Rep. in 2007 to that in 2008?
Your answer should be very brief. 1.65. What is the ratio of the Balance of Payment (as % of service exports) of European Union in 2007 to that in 2009?
Keep it short and to the point. 0.94. What is the ratio of the Balance of Payment (as % of service exports) in Sao Tome and Principe in 2007 to that in 2009?
Your answer should be very brief. 1.26. What is the ratio of the Balance of Payment (as % of service exports) of Togo in 2007 to that in 2009?
Your response must be concise. 0.65. What is the ratio of the Balance of Payment (as % of service exports) in Yemen, Rep. in 2007 to that in 2009?
Your answer should be very brief. 1.72. What is the ratio of the Balance of Payment (as % of service exports) in European Union in 2007 to that in 2010?
Make the answer very short. 0.92. What is the ratio of the Balance of Payment (as % of service exports) of Sao Tome and Principe in 2007 to that in 2010?
Give a very brief answer. 1.51. What is the ratio of the Balance of Payment (as % of service exports) of Togo in 2007 to that in 2010?
Your answer should be very brief. 0.85. What is the ratio of the Balance of Payment (as % of service exports) of Yemen, Rep. in 2007 to that in 2010?
Ensure brevity in your answer.  2.05. What is the ratio of the Balance of Payment (as % of service exports) in European Union in 2007 to that in 2011?
Make the answer very short. 0.92. What is the ratio of the Balance of Payment (as % of service exports) of Sao Tome and Principe in 2007 to that in 2011?
Offer a terse response. 1.89. What is the ratio of the Balance of Payment (as % of service exports) in Togo in 2007 to that in 2011?
Ensure brevity in your answer.  0.98. What is the ratio of the Balance of Payment (as % of service exports) in Yemen, Rep. in 2007 to that in 2011?
Keep it short and to the point. 1.45. What is the ratio of the Balance of Payment (as % of service exports) of European Union in 2008 to that in 2009?
Give a very brief answer. 0.96. What is the ratio of the Balance of Payment (as % of service exports) of Togo in 2008 to that in 2009?
Ensure brevity in your answer.  1.03. What is the ratio of the Balance of Payment (as % of service exports) in Yemen, Rep. in 2008 to that in 2009?
Your answer should be compact. 1.05. What is the ratio of the Balance of Payment (as % of service exports) of European Union in 2008 to that in 2010?
Offer a terse response. 0.94. What is the ratio of the Balance of Payment (as % of service exports) of Sao Tome and Principe in 2008 to that in 2010?
Offer a terse response. 1.19. What is the ratio of the Balance of Payment (as % of service exports) of Togo in 2008 to that in 2010?
Your response must be concise. 1.35. What is the ratio of the Balance of Payment (as % of service exports) in Yemen, Rep. in 2008 to that in 2010?
Keep it short and to the point. 1.24. What is the ratio of the Balance of Payment (as % of service exports) in Sao Tome and Principe in 2008 to that in 2011?
Provide a short and direct response. 1.49. What is the ratio of the Balance of Payment (as % of service exports) in Togo in 2008 to that in 2011?
Keep it short and to the point. 1.55. What is the ratio of the Balance of Payment (as % of service exports) in Yemen, Rep. in 2008 to that in 2011?
Your answer should be very brief. 0.88. What is the ratio of the Balance of Payment (as % of service exports) in European Union in 2009 to that in 2010?
Keep it short and to the point. 0.99. What is the ratio of the Balance of Payment (as % of service exports) in Sao Tome and Principe in 2009 to that in 2010?
Your answer should be compact. 1.19. What is the ratio of the Balance of Payment (as % of service exports) in Togo in 2009 to that in 2010?
Your answer should be very brief. 1.32. What is the ratio of the Balance of Payment (as % of service exports) of Yemen, Rep. in 2009 to that in 2010?
Your answer should be compact. 1.19. What is the ratio of the Balance of Payment (as % of service exports) of European Union in 2009 to that in 2011?
Ensure brevity in your answer.  0.98. What is the ratio of the Balance of Payment (as % of service exports) of Sao Tome and Principe in 2009 to that in 2011?
Make the answer very short. 1.5. What is the ratio of the Balance of Payment (as % of service exports) in Togo in 2009 to that in 2011?
Provide a short and direct response. 1.51. What is the ratio of the Balance of Payment (as % of service exports) of Yemen, Rep. in 2009 to that in 2011?
Your answer should be compact. 0.84. What is the ratio of the Balance of Payment (as % of service exports) in European Union in 2010 to that in 2011?
Your response must be concise. 0.99. What is the ratio of the Balance of Payment (as % of service exports) of Sao Tome and Principe in 2010 to that in 2011?
Give a very brief answer. 1.25. What is the ratio of the Balance of Payment (as % of service exports) in Togo in 2010 to that in 2011?
Your answer should be very brief. 1.14. What is the ratio of the Balance of Payment (as % of service exports) in Yemen, Rep. in 2010 to that in 2011?
Make the answer very short. 0.71. What is the difference between the highest and the second highest Balance of Payment (as % of service exports) of European Union?
Offer a terse response. 0.25. What is the difference between the highest and the second highest Balance of Payment (as % of service exports) in Sao Tome and Principe?
Offer a very short reply. 1.43. What is the difference between the highest and the second highest Balance of Payment (as % of service exports) in Togo?
Give a very brief answer. 0.77. What is the difference between the highest and the second highest Balance of Payment (as % of service exports) in Yemen, Rep.?
Keep it short and to the point. 3.69. What is the difference between the highest and the lowest Balance of Payment (as % of service exports) of European Union?
Your response must be concise. 3.07. What is the difference between the highest and the lowest Balance of Payment (as % of service exports) of Sao Tome and Principe?
Provide a short and direct response. 7.01. What is the difference between the highest and the lowest Balance of Payment (as % of service exports) in Togo?
Keep it short and to the point. 11.61. What is the difference between the highest and the lowest Balance of Payment (as % of service exports) of Yemen, Rep.?
Provide a short and direct response. 12.2. 